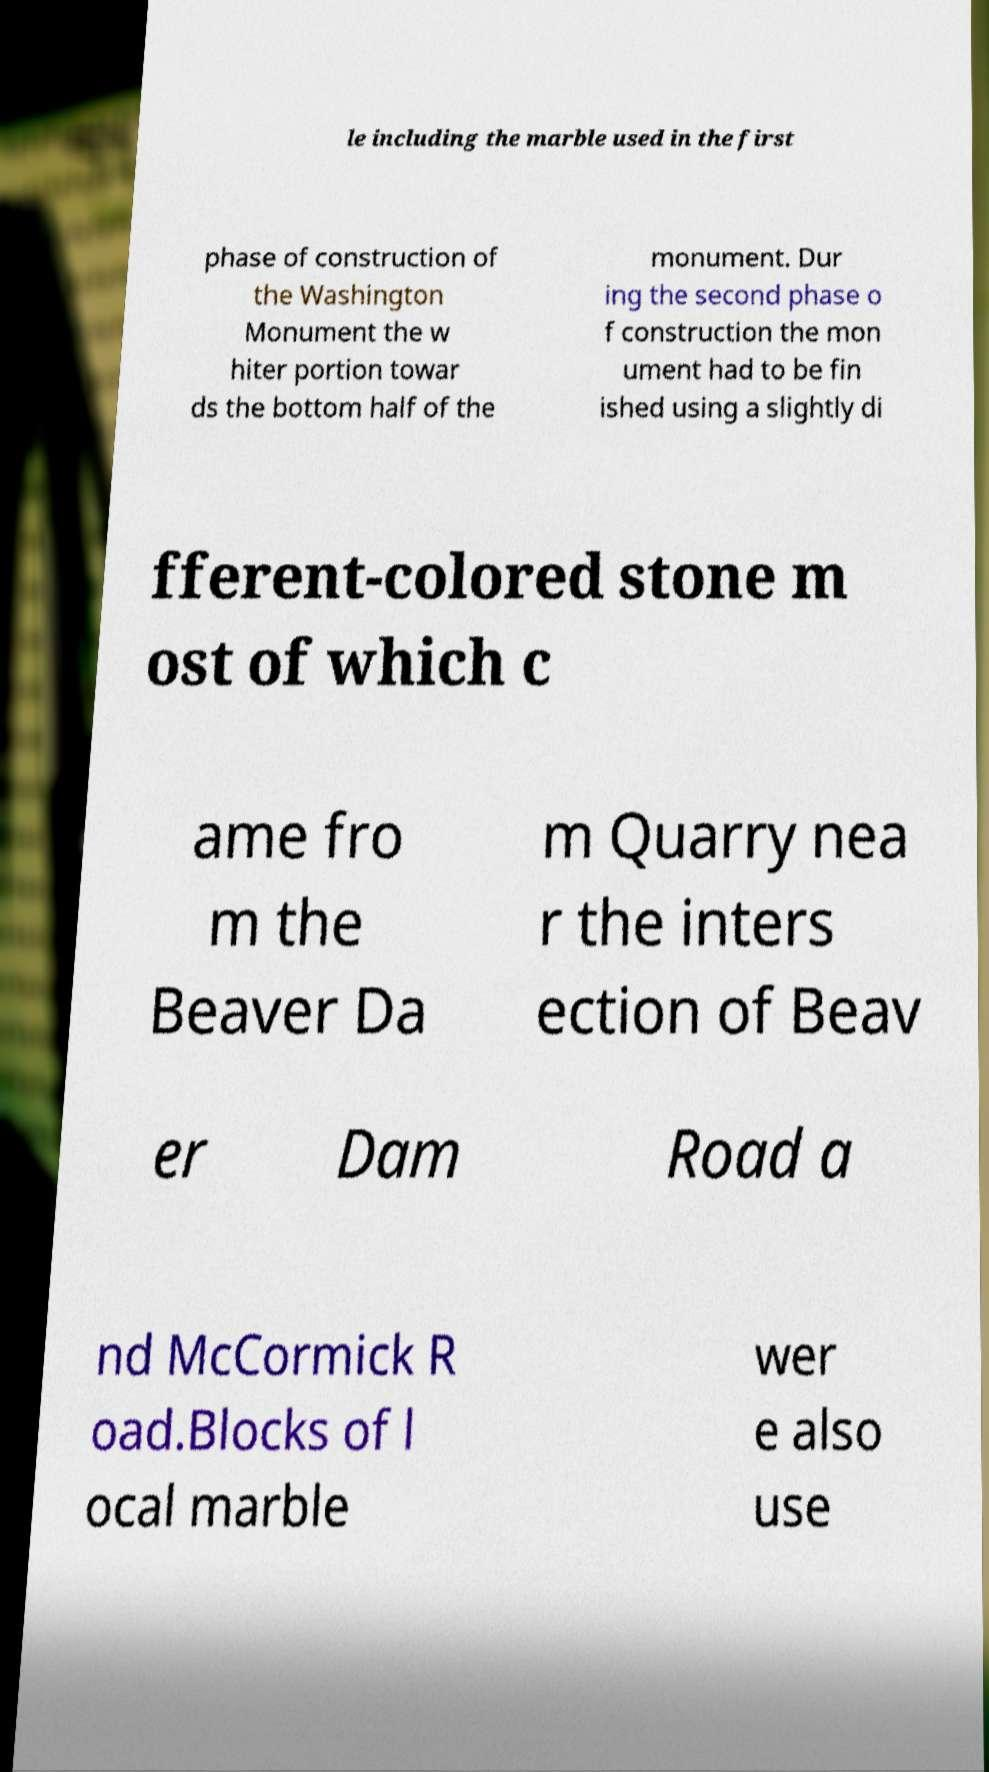Please read and relay the text visible in this image. What does it say? le including the marble used in the first phase of construction of the Washington Monument the w hiter portion towar ds the bottom half of the monument. Dur ing the second phase o f construction the mon ument had to be fin ished using a slightly di fferent-colored stone m ost of which c ame fro m the Beaver Da m Quarry nea r the inters ection of Beav er Dam Road a nd McCormick R oad.Blocks of l ocal marble wer e also use 